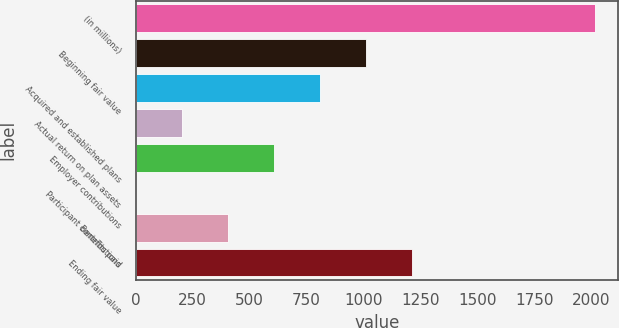<chart> <loc_0><loc_0><loc_500><loc_500><bar_chart><fcel>(in millions)<fcel>Beginning fair value<fcel>Acquired and established plans<fcel>Actual return on plan assets<fcel>Employer contributions<fcel>Participant contributions<fcel>Benefits paid<fcel>Ending fair value<nl><fcel>2017<fcel>1009<fcel>807.4<fcel>202.6<fcel>605.8<fcel>1<fcel>404.2<fcel>1210.6<nl></chart> 